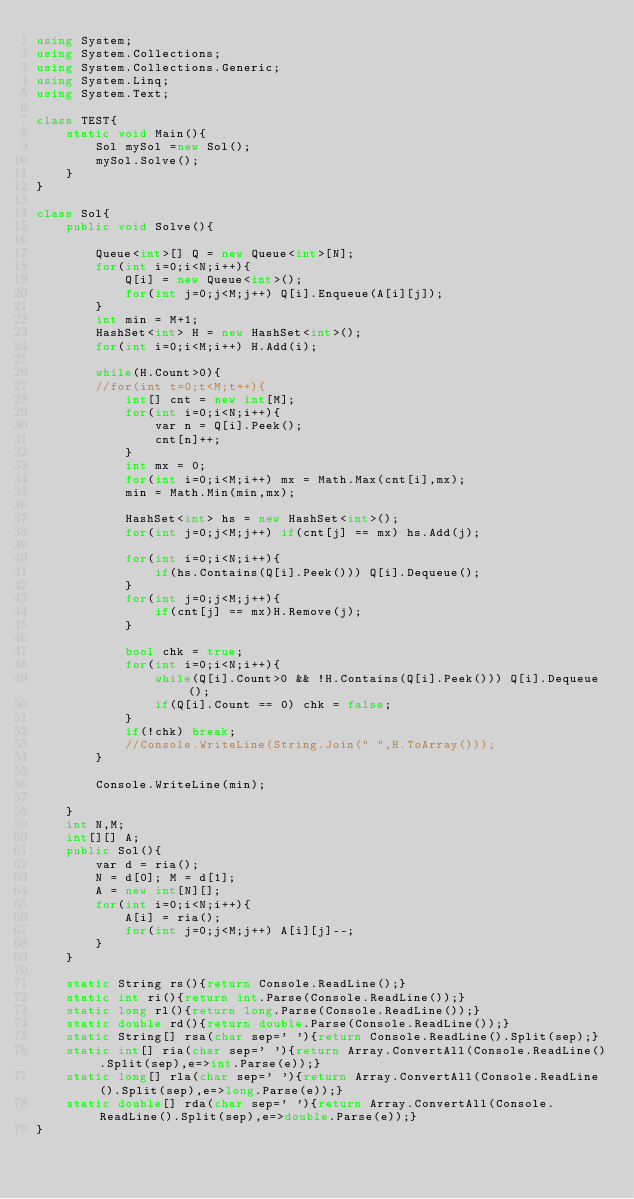<code> <loc_0><loc_0><loc_500><loc_500><_C#_>using System;
using System.Collections;
using System.Collections.Generic;
using System.Linq;
using System.Text;

class TEST{
	static void Main(){
		Sol mySol =new Sol();
		mySol.Solve();
	}
}

class Sol{
	public void Solve(){
		
		Queue<int>[] Q = new Queue<int>[N];
		for(int i=0;i<N;i++){
			Q[i] = new Queue<int>();
			for(int j=0;j<M;j++) Q[i].Enqueue(A[i][j]);
		}
		int min = M+1;
		HashSet<int> H = new HashSet<int>();
		for(int i=0;i<M;i++) H.Add(i);
		
		while(H.Count>0){
		//for(int t=0;t<M;t++){
			int[] cnt = new int[M];
			for(int i=0;i<N;i++){
				var n = Q[i].Peek();
				cnt[n]++;
			}
			int mx = 0;
			for(int i=0;i<M;i++) mx = Math.Max(cnt[i],mx);
			min = Math.Min(min,mx);
			
			HashSet<int> hs = new HashSet<int>();
			for(int j=0;j<M;j++) if(cnt[j] == mx) hs.Add(j);
			
			for(int i=0;i<N;i++){
				if(hs.Contains(Q[i].Peek())) Q[i].Dequeue();
			}
			for(int j=0;j<M;j++){
				if(cnt[j] == mx)H.Remove(j);
			}
			
			bool chk = true;
			for(int i=0;i<N;i++){
				while(Q[i].Count>0 && !H.Contains(Q[i].Peek())) Q[i].Dequeue();
				if(Q[i].Count == 0) chk = false;
			}
			if(!chk) break;
			//Console.WriteLine(String.Join(" ",H.ToArray()));
		}
		
		Console.WriteLine(min);
		
	}
	int N,M;
	int[][] A;
	public Sol(){
		var d = ria();
		N = d[0]; M = d[1];
		A = new int[N][];
		for(int i=0;i<N;i++){
			A[i] = ria();
			for(int j=0;j<M;j++) A[i][j]--;
		}
	}

	static String rs(){return Console.ReadLine();}
	static int ri(){return int.Parse(Console.ReadLine());}
	static long rl(){return long.Parse(Console.ReadLine());}
	static double rd(){return double.Parse(Console.ReadLine());}
	static String[] rsa(char sep=' '){return Console.ReadLine().Split(sep);}
	static int[] ria(char sep=' '){return Array.ConvertAll(Console.ReadLine().Split(sep),e=>int.Parse(e));}
	static long[] rla(char sep=' '){return Array.ConvertAll(Console.ReadLine().Split(sep),e=>long.Parse(e));}
	static double[] rda(char sep=' '){return Array.ConvertAll(Console.ReadLine().Split(sep),e=>double.Parse(e));}
}
</code> 